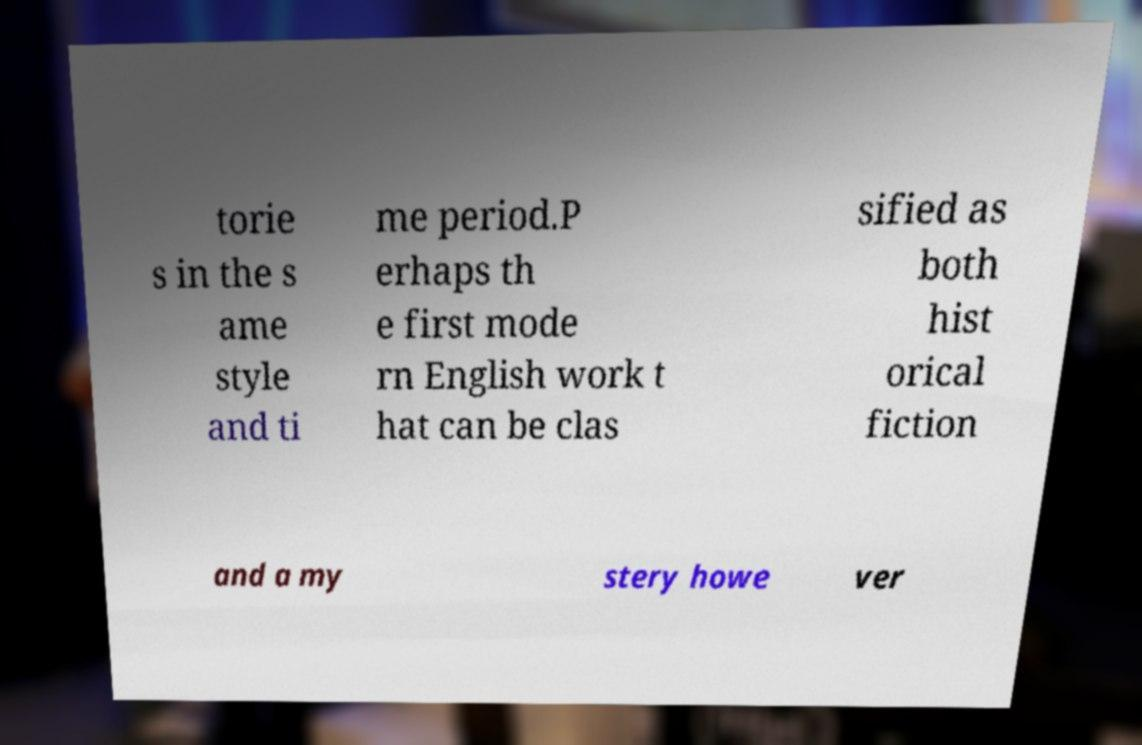Can you read and provide the text displayed in the image?This photo seems to have some interesting text. Can you extract and type it out for me? torie s in the s ame style and ti me period.P erhaps th e first mode rn English work t hat can be clas sified as both hist orical fiction and a my stery howe ver 